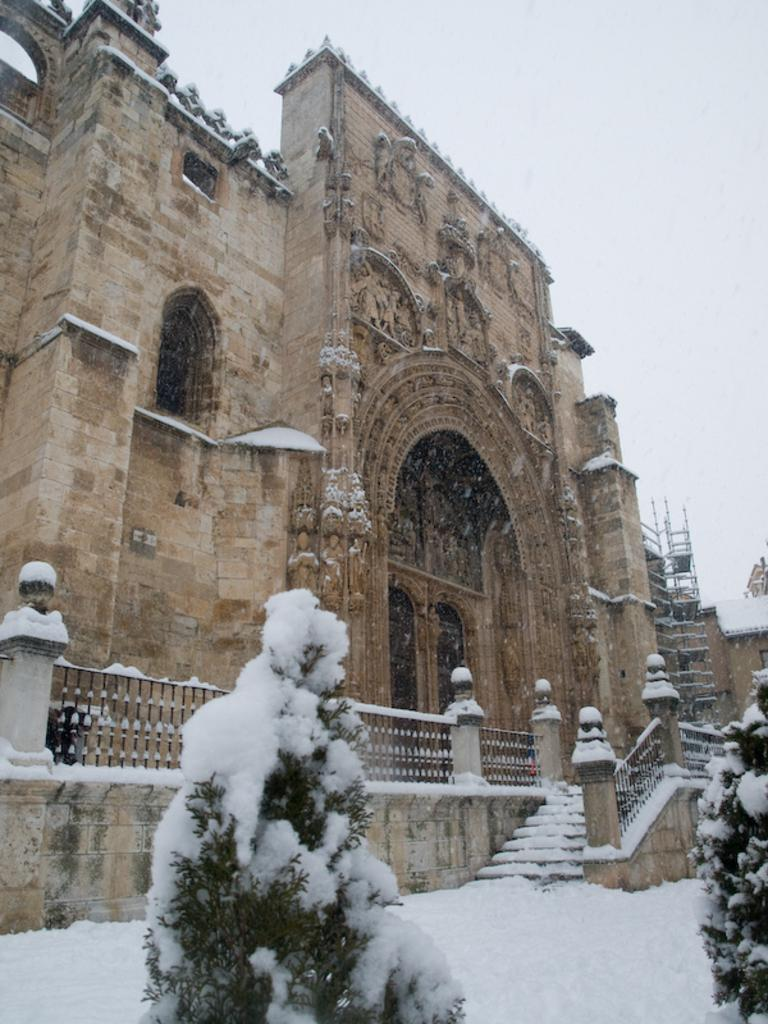What type of structure is visible in the image? There is an architecture in the image. What is the condition of the ground in front of the architecture? There is a lot of snow in front of the architecture. How are the trees affected by the weather in the image? The trees are covered with ice. What type of agreement can be seen between the architecture and the trees in the image? There is no agreement between the architecture and the trees in the image; they are separate entities. 